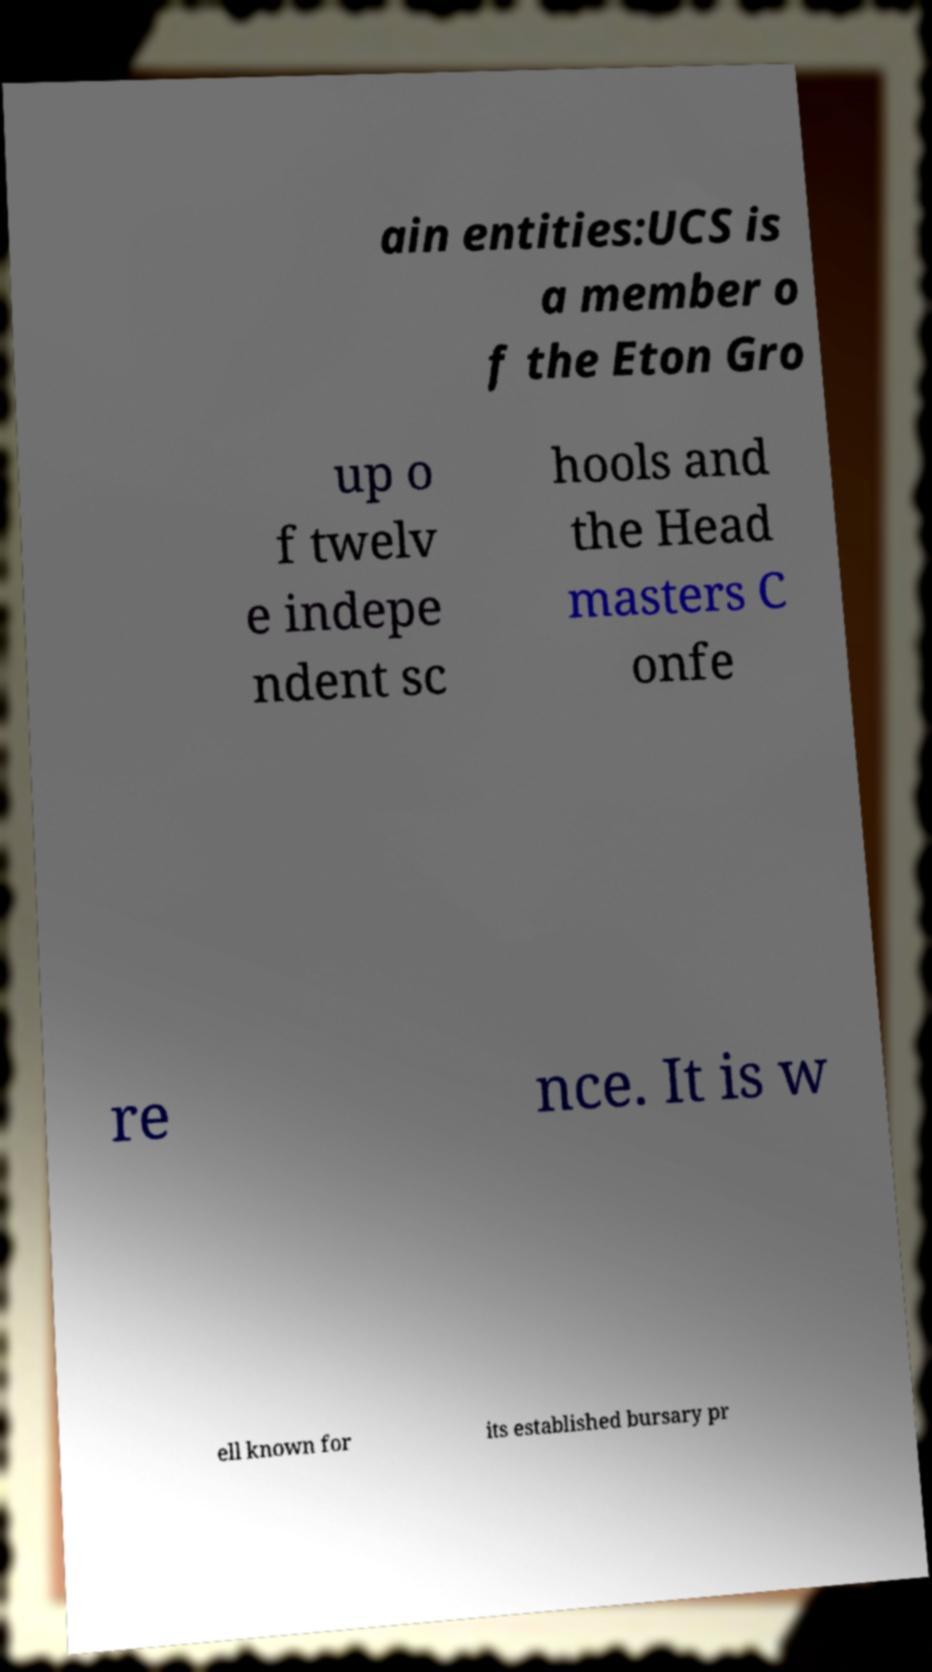There's text embedded in this image that I need extracted. Can you transcribe it verbatim? ain entities:UCS is a member o f the Eton Gro up o f twelv e indepe ndent sc hools and the Head masters C onfe re nce. It is w ell known for its established bursary pr 